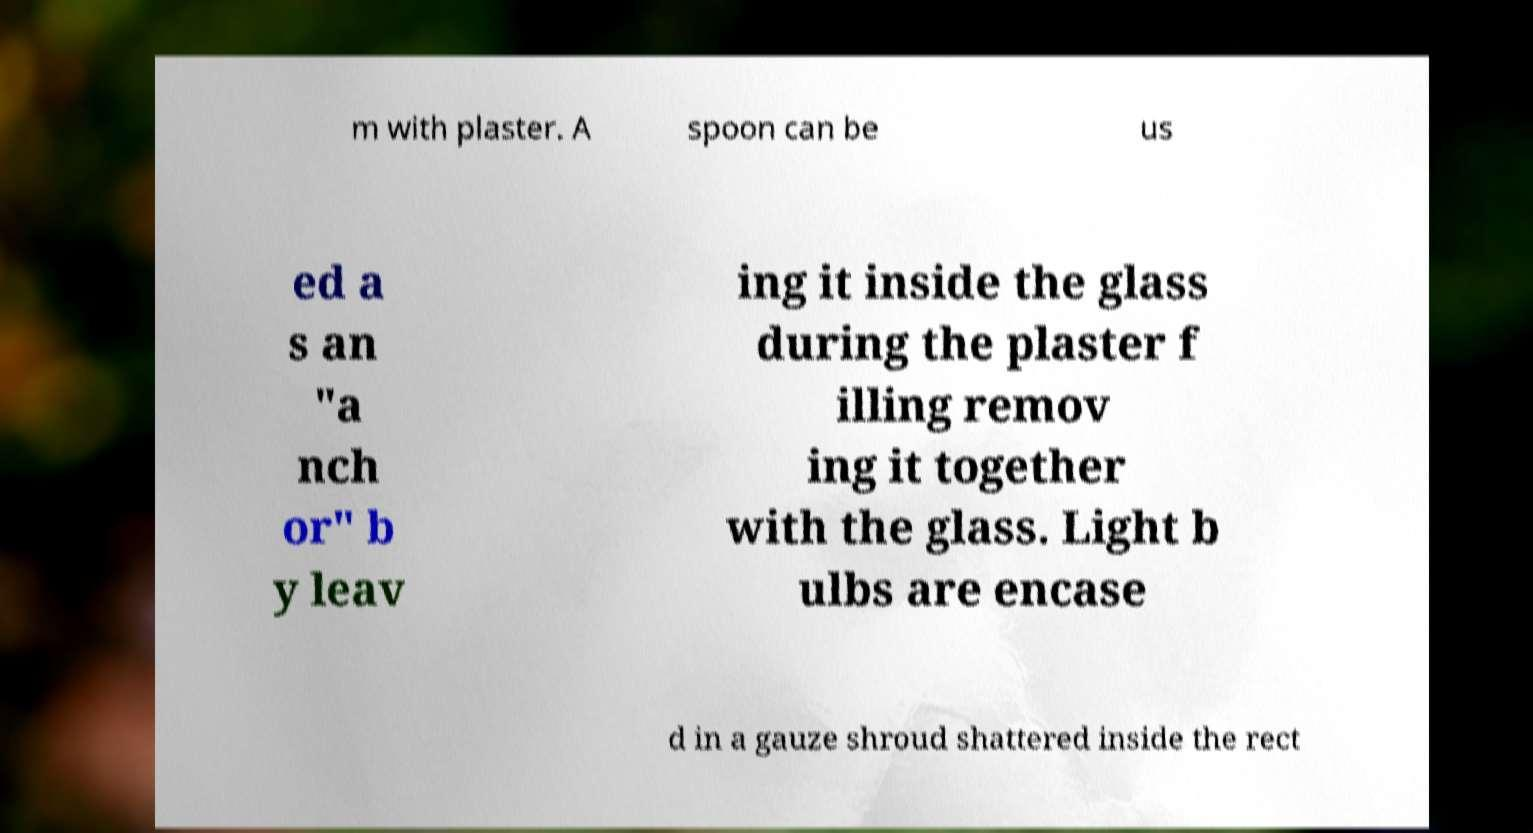There's text embedded in this image that I need extracted. Can you transcribe it verbatim? m with plaster. A spoon can be us ed a s an "a nch or" b y leav ing it inside the glass during the plaster f illing remov ing it together with the glass. Light b ulbs are encase d in a gauze shroud shattered inside the rect 